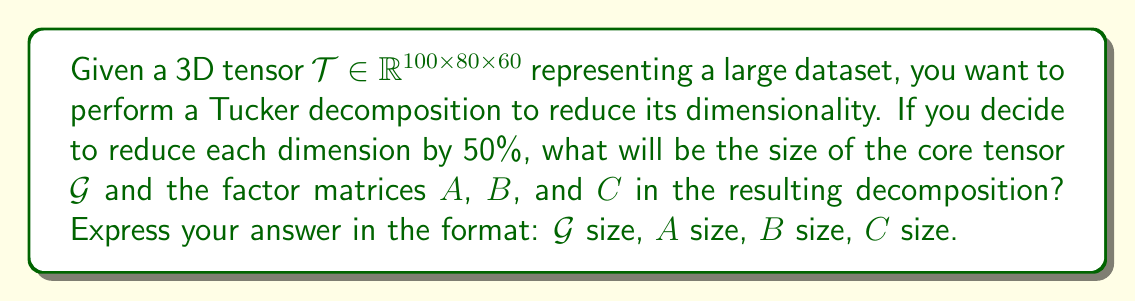Could you help me with this problem? To solve this problem, let's follow these steps:

1) Recall that Tucker decomposition of a 3D tensor $\mathcal{T} \in \mathbb{R}^{I \times J \times K}$ is given by:

   $$\mathcal{T} \approx \mathcal{G} \times_1 A \times_2 B \times_3 C$$

   where $\mathcal{G}$ is the core tensor and $A$, $B$, and $C$ are the factor matrices.

2) The original tensor $\mathcal{T}$ has dimensions $100 \times 80 \times 60$.

3) We want to reduce each dimension by 50%. This means:
   - The first dimension will be reduced from 100 to 50
   - The second dimension will be reduced from 80 to 40
   - The third dimension will be reduced from 60 to 30

4) In Tucker decomposition:
   - The core tensor $\mathcal{G}$ will have the reduced dimensions: $50 \times 40 \times 30$
   - The factor matrix $A$ will have size $100 \times 50$ (original first dimension × reduced first dimension)
   - The factor matrix $B$ will have size $80 \times 40$ (original second dimension × reduced second dimension)
   - The factor matrix $C$ will have size $60 \times 30$ (original third dimension × reduced third dimension)

5) Therefore, the sizes of the resulting components are:
   - $\mathcal{G}$: $50 \times 40 \times 30$
   - $A$: $100 \times 50$
   - $B$: $80 \times 40$
   - $C$: $60 \times 30$
Answer: $50 \times 40 \times 30$, $100 \times 50$, $80 \times 40$, $60 \times 30$ 